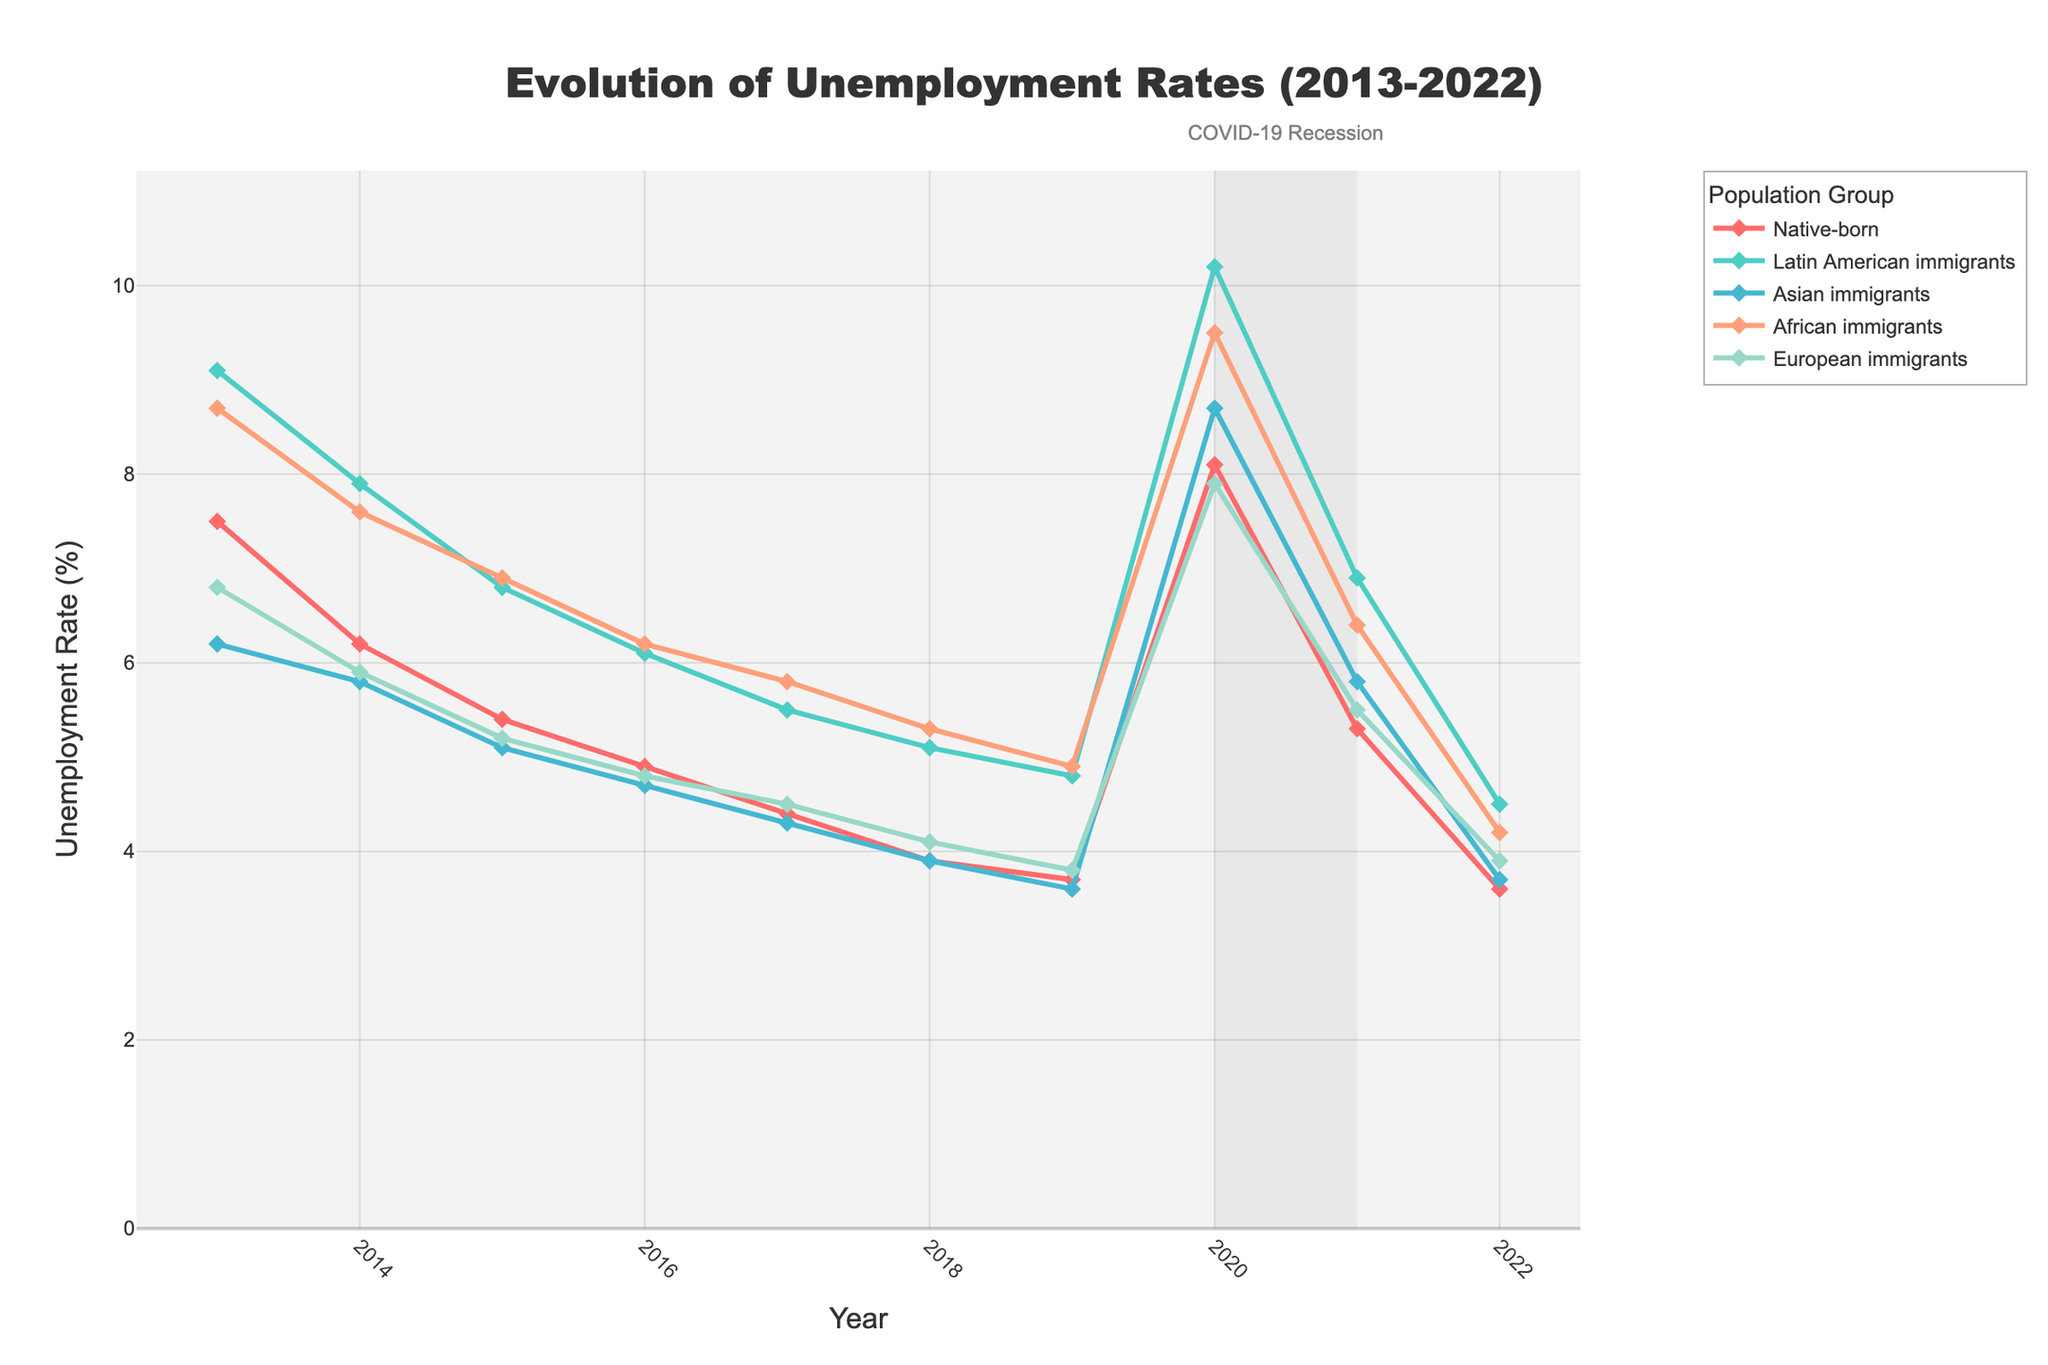What was the trend in unemployment rates for Latin American immigrants between 2013 and 2022? The trend for Latin American immigrants shows a general decrease in unemployment rates from 2013 (9.1%) to 2022 (4.5%), with a rise in 2020 due to the COVID-19 recession.
Answer: General decrease Which group had the highest unemployment rate in 2020? By observing the plot for 2020, Latin American immigrants had the highest unemployment rate at 10.2%.
Answer: Latin American immigrants How did the unemployment rate for native-born residents in 2022 compare to their rate in 2013? The unemployment rate for native-born residents in 2022 was 3.6%, down from 7.5% in 2013, indicating a decrease of 3.9 percentage points.
Answer: Decreased by 3.9 percentage points During the COVID-19 recession, which group experienced the smallest increase in unemployment rates compared to 2019? Compare the difference in unemployment rates from 2019 to 2020 for all groups. Asian immigrants had an increase from 3.6% to 8.7% (5.1 percentage points). This is the smallest increase among the groups.
Answer: Asian immigrants What is the average unemployment rate for European immigrants over the last decade? Sum the unemployment rates for each year and divide by the number of years: (6.8 + 5.9 + 5.2 + 4.8 + 4.5 + 4.1 + 3.8 + 7.9 + 5.5 + 3.9) / 10. This equals 52.4 / 10 = 5.24%.
Answer: 5.24% In which year did African immigrants experience the highest unemployment rate? Reviewing the plot, the highest unemployment rate for African immigrants was in 2020, with a rate of 9.5%.
Answer: 2020 Between 2018 and 2019, which group saw the largest decline in unemployment rate? Compare the rate changes between 2018 and 2019 for all groups. Asian immigrants experienced the largest decline from 3.9% to 3.6%, which is a 0.3 percentage point decrease.
Answer: Asian immigrants What is the percentage point difference between the unemployment rates of native-born residents and African immigrants in 2022? In 2022, the unemployment rate for native-born residents was 3.6%, and for African immigrants it was 4.2%. The difference is 4.2% - 3.6% = 0.6 percentage points.
Answer: 0.6 percentage points Which group's unemployment rate remained consistently lower than the native-born residents throughout the decade? Observing the plot, Asian immigrants' unemployment rate remained consistently lower than that of native-born residents throughout the decade.
Answer: Asian immigrants 